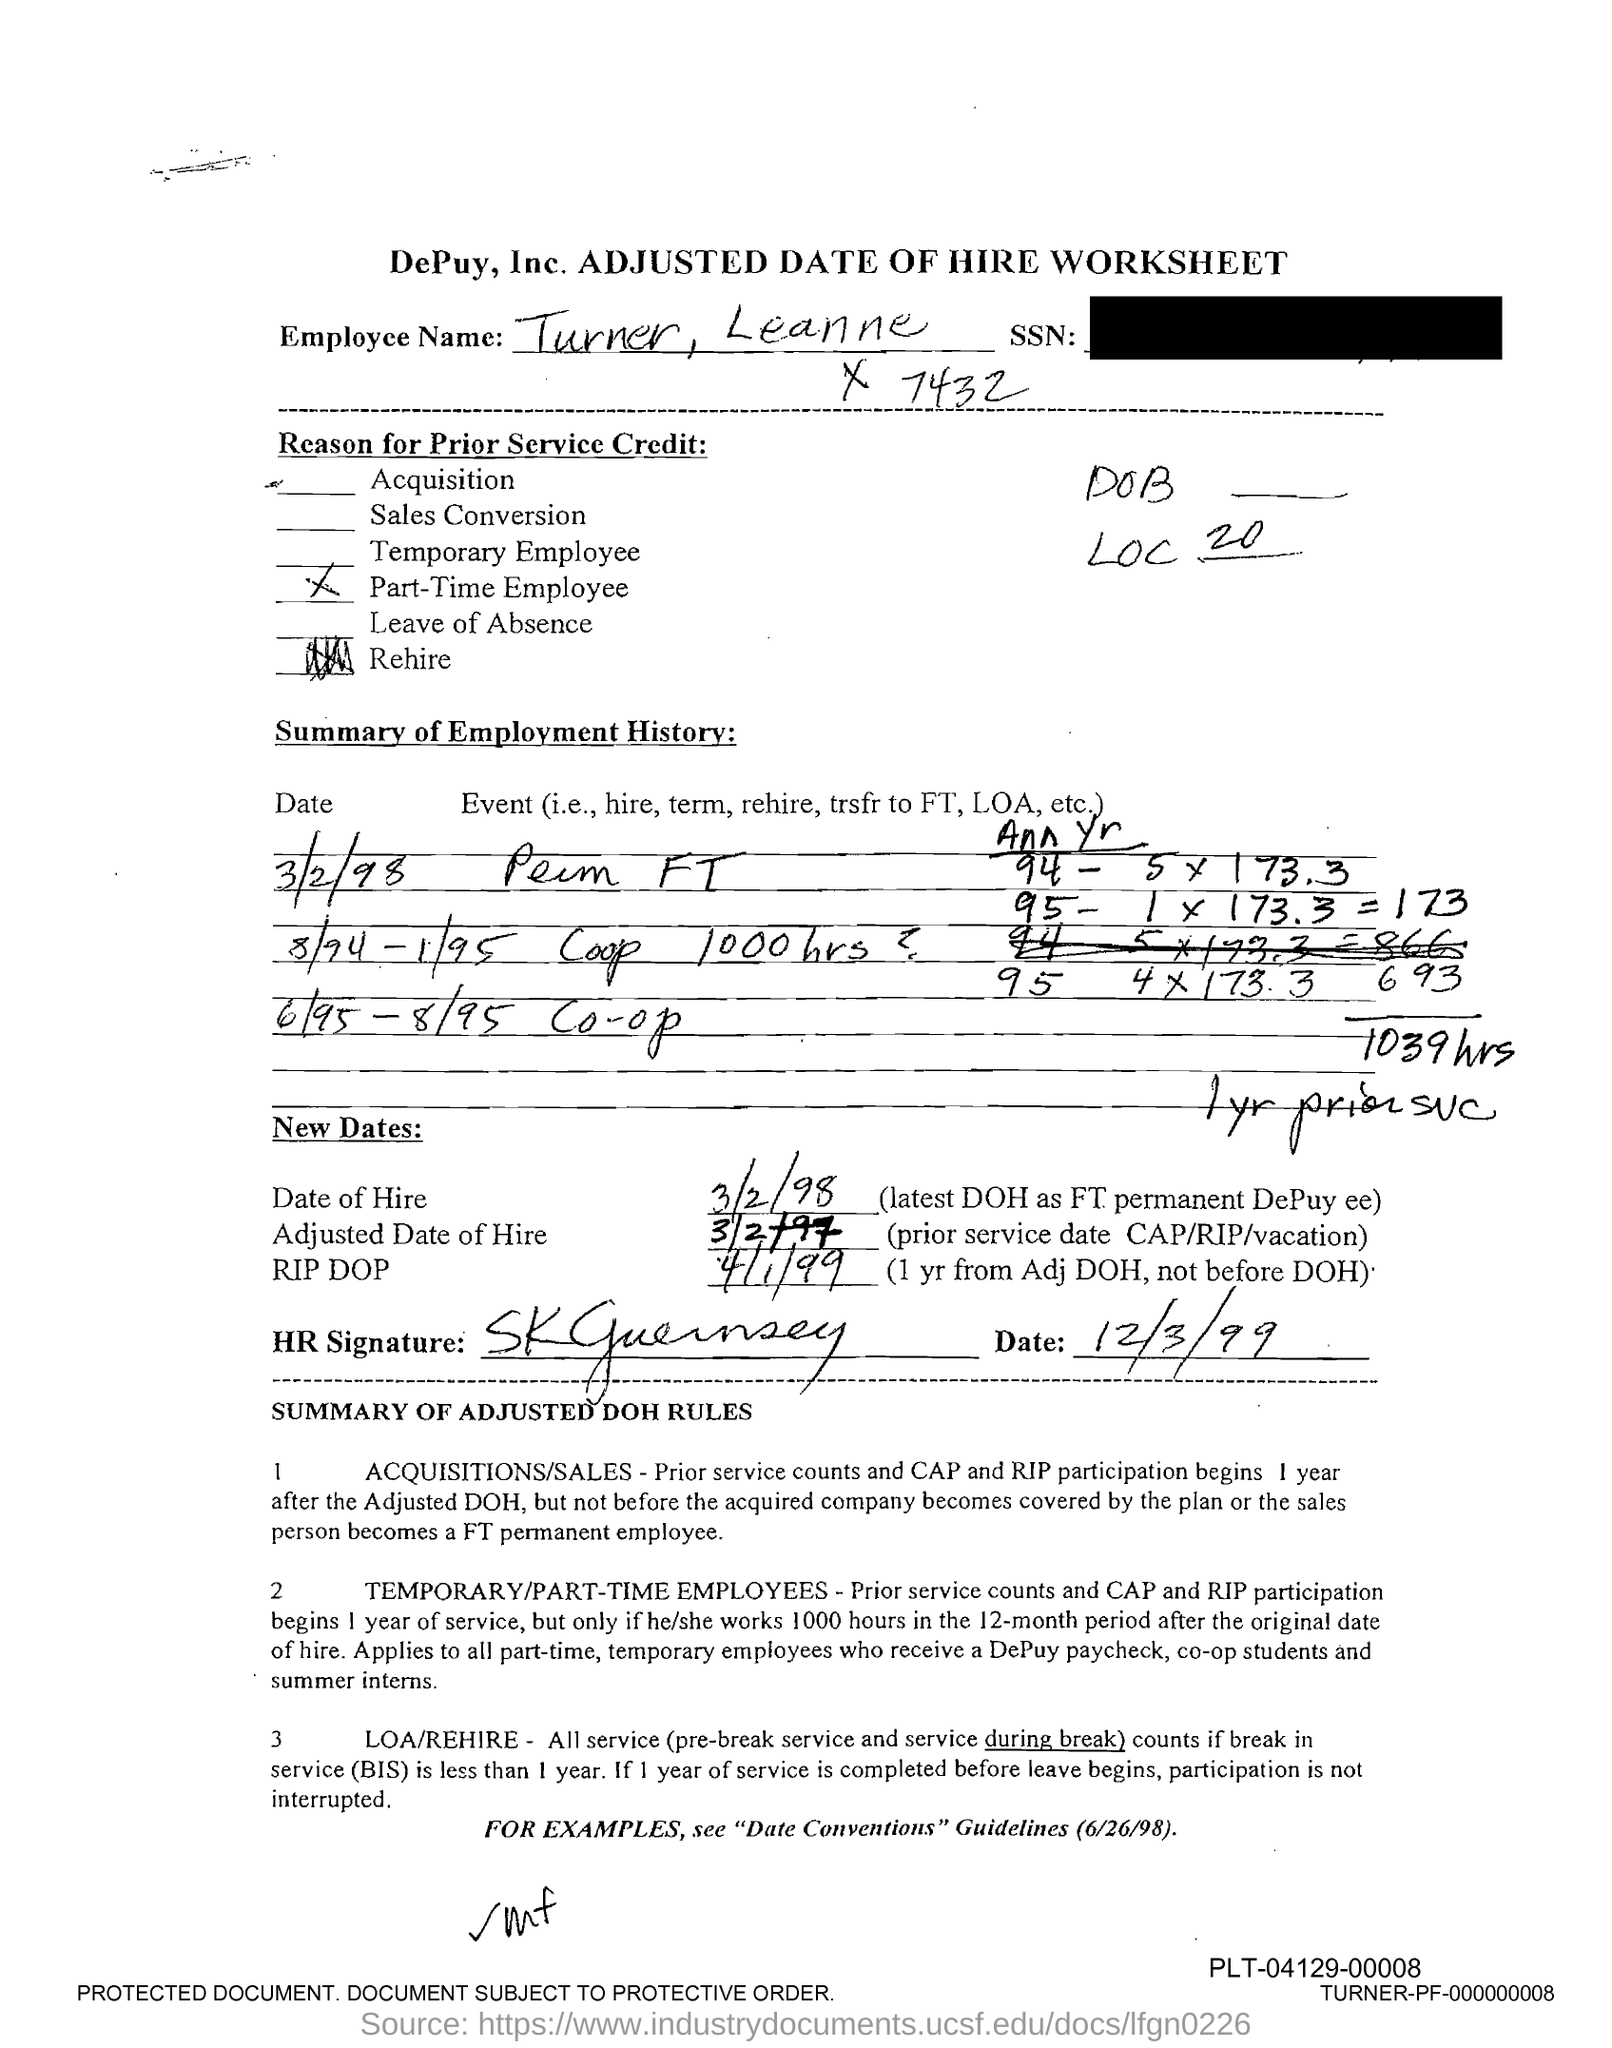Draw attention to some important aspects in this diagram. What is the adjusted date of hire? It is 3/2/97. The date of hire is March 2, 1998. 